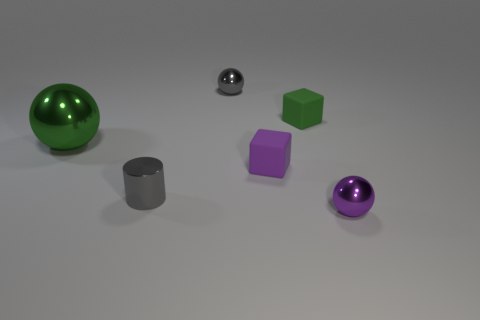Add 3 small gray shiny objects. How many objects exist? 9 Subtract all cubes. How many objects are left? 4 Subtract 1 green balls. How many objects are left? 5 Subtract all tiny green metal cubes. Subtract all green cubes. How many objects are left? 5 Add 3 tiny purple objects. How many tiny purple objects are left? 5 Add 5 tiny objects. How many tiny objects exist? 10 